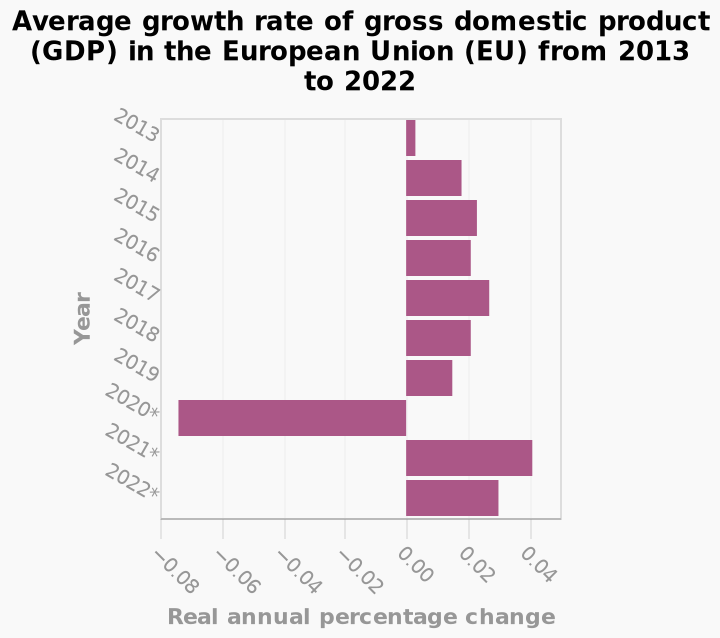<image>
please summary the statistics and relations of the chart EU GDP growth rate decreased in 2020From 2013 to 2022 the EU GDP growth was rising. What happened to the EU GDP growth rate in 2020?  The EU GDP growth rate decreased in 2020. What was the trend of the EU GDP growth rate before 2020? The EU GDP growth rate was rising before 2020. In which year did the EU experience a decrease in GDP growth rate?  The EU experienced a decrease in GDP growth rate in 2020. Was there any change in the EU's GDP growth rate from 2013 to 2022? Yes, the EU's GDP growth rate was rising from 2013 to 2022. 